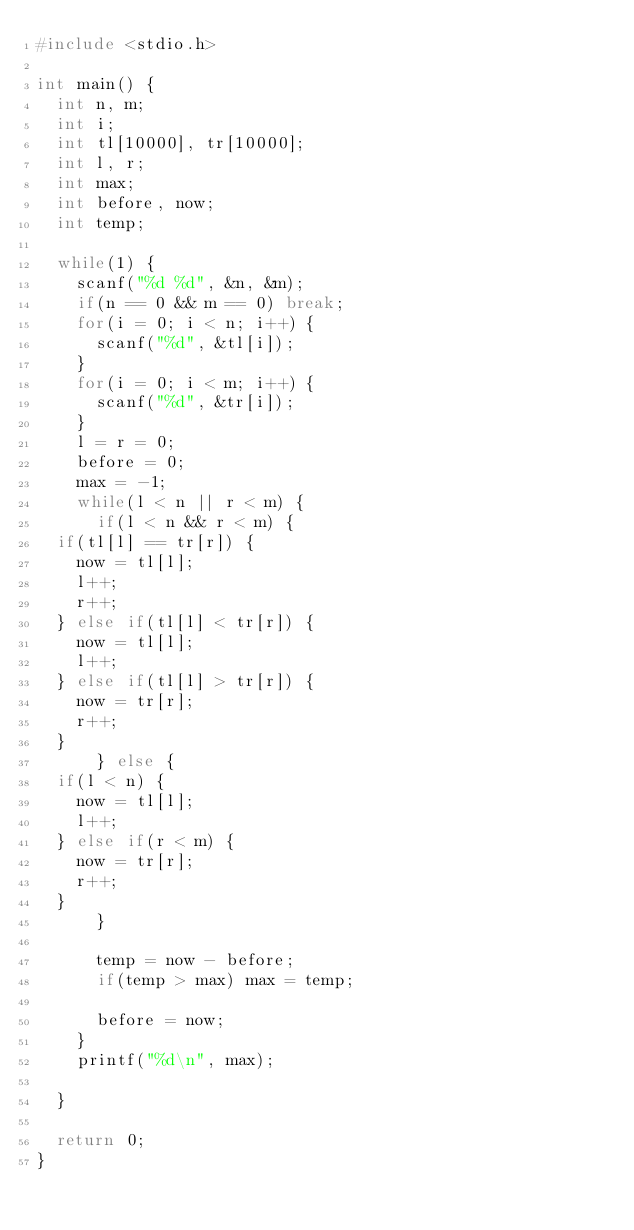<code> <loc_0><loc_0><loc_500><loc_500><_C_>#include <stdio.h>

int main() {
  int n, m;
  int i;
  int tl[10000], tr[10000];
  int l, r;
  int max;
  int before, now;
  int temp;

  while(1) {
    scanf("%d %d", &n, &m);
    if(n == 0 && m == 0) break;
    for(i = 0; i < n; i++) {
      scanf("%d", &tl[i]);
    }
    for(i = 0; i < m; i++) {
      scanf("%d", &tr[i]);
    }
    l = r = 0;
    before = 0;
    max = -1;
    while(l < n || r < m) {
      if(l < n && r < m) {
	if(tl[l] == tr[r]) {
	  now = tl[l];
	  l++;
	  r++;
	} else if(tl[l] < tr[r]) {
	  now = tl[l];
	  l++;
	} else if(tl[l] > tr[r]) {
	  now = tr[r];
	  r++;
	}
      } else {
	if(l < n) {
	  now = tl[l];
	  l++;
	} else if(r < m) {
	  now = tr[r];
	  r++;
	}
      }

      temp = now - before;
      if(temp > max) max = temp;
      
      before = now;
    }
    printf("%d\n", max);

  }

  return 0;
}</code> 